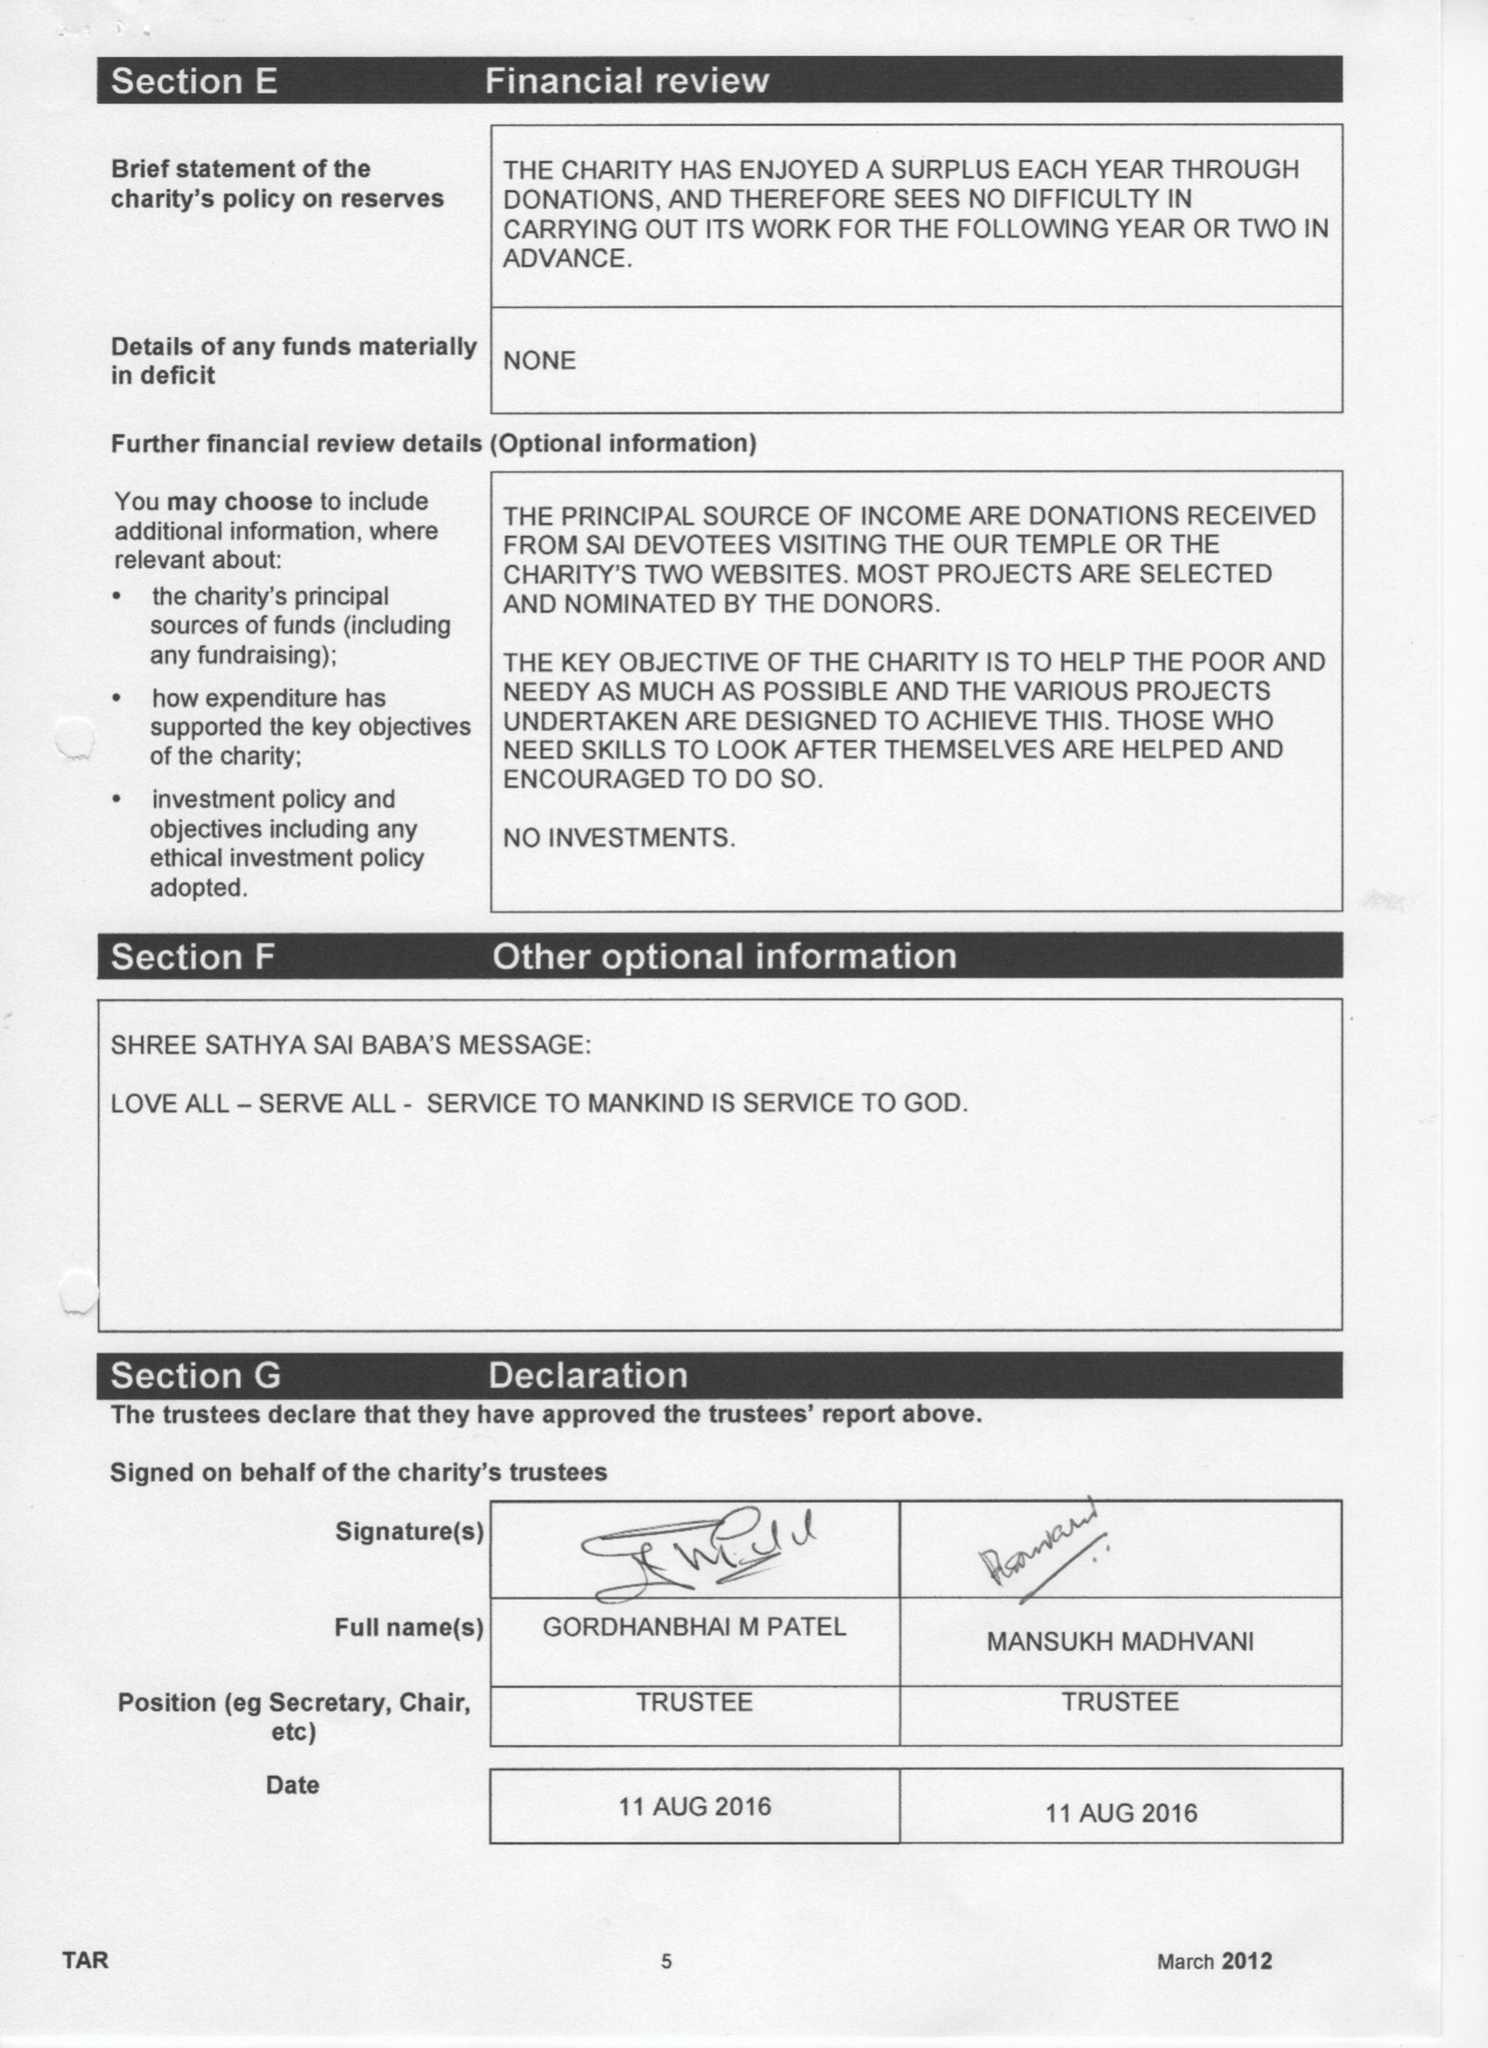What is the value for the report_date?
Answer the question using a single word or phrase. 2015-11-30 